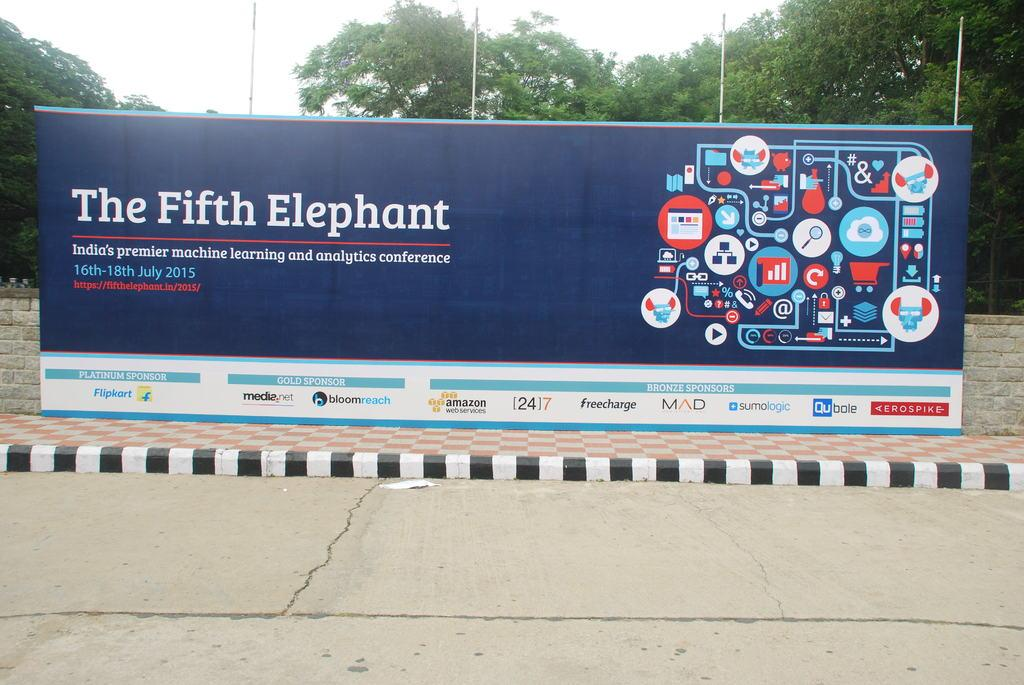What is located beside the footpath in the image? There is a banner beside the footpath in the image. What is the banner placed in front of? The banner is in front of a wall. What text is written on the banner? The banner has the text "THE FIFTH ELEPHANT" on it. What can be seen in the background of the image? There are trees and poles in the background of the image. Where is the grandfather sitting in the image? There is no grandfather present in the image. What type of animal can be seen walking in the background of the image? There are no animals visible in the image, including giraffes. 